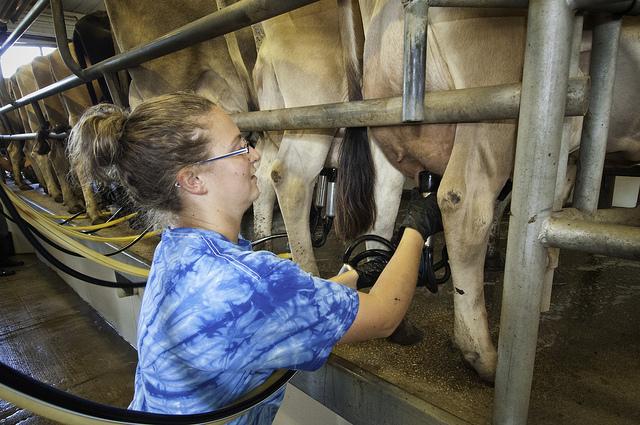What is she doing to those animals?
Be succinct. Milking. What is she attempting to get from the animal?
Keep it brief. Milk. What type of shirt is she wearing?
Keep it brief. Tie dye. Is the woman feeding the animal?
Be succinct. No. 